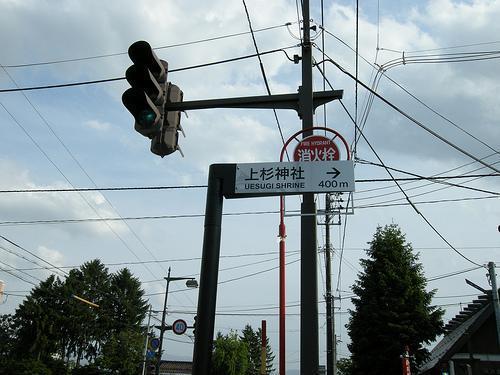How many traffic lights are there?
Give a very brief answer. 2. 